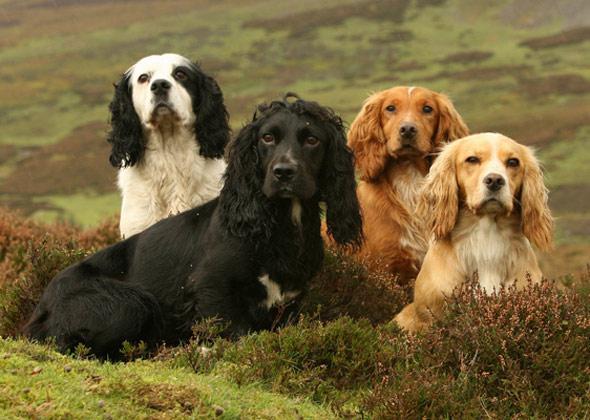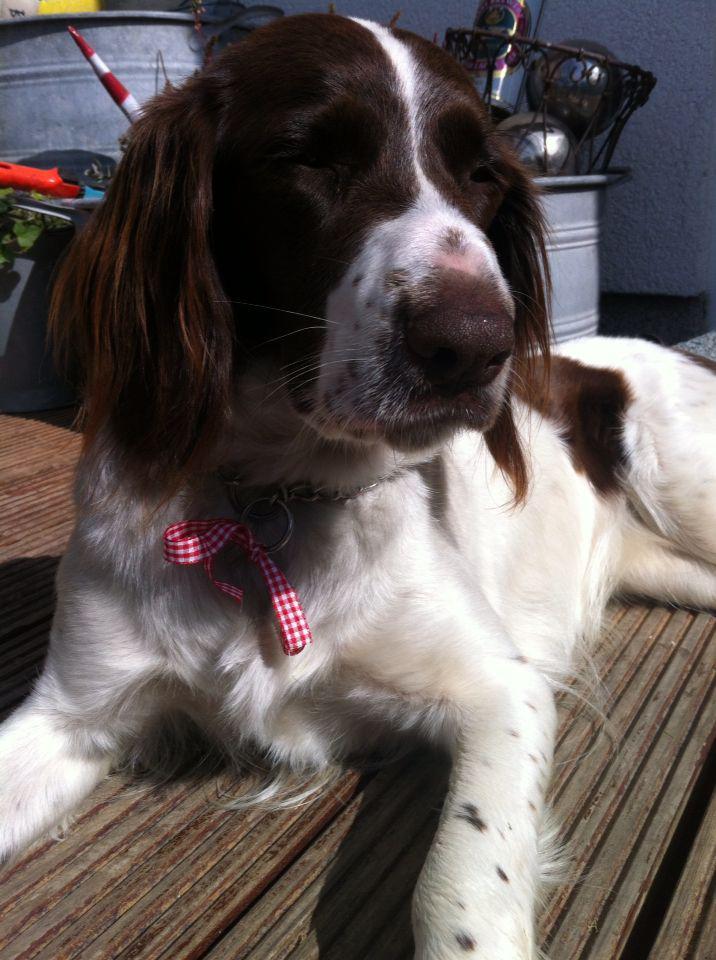The first image is the image on the left, the second image is the image on the right. Given the left and right images, does the statement "A human is touching the dog in the image on the left." hold true? Answer yes or no. No. The first image is the image on the left, the second image is the image on the right. For the images displayed, is the sentence "The left image contains a human hand touching a black and white dog." factually correct? Answer yes or no. No. 